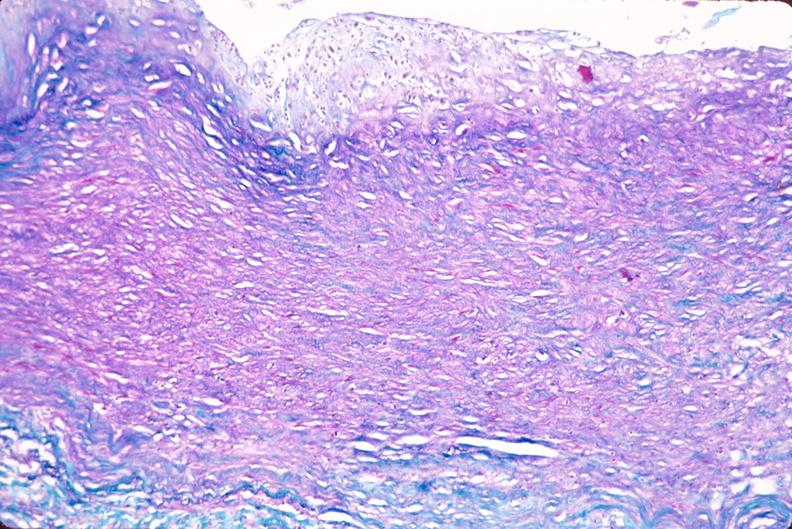what does this image show?
Answer the question using a single word or phrase. Saphenous vein graft sclerosis 